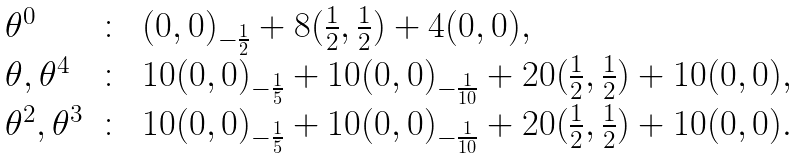Convert formula to latex. <formula><loc_0><loc_0><loc_500><loc_500>\begin{array} { l c l } \theta ^ { 0 } & \colon & ( 0 , 0 ) _ { - \frac { 1 } { 2 } } + 8 ( \frac { 1 } { 2 } , \frac { 1 } { 2 } ) + 4 ( 0 , 0 ) , \\ \theta , \theta ^ { 4 } & \colon & 1 0 ( 0 , 0 ) _ { - \frac { 1 } { 5 } } + 1 0 ( 0 , 0 ) _ { - \frac { 1 } { 1 0 } } + 2 0 ( \frac { 1 } { 2 } , \frac { 1 } { 2 } ) + 1 0 ( 0 , 0 ) , \\ \theta ^ { 2 } , \theta ^ { 3 } & \colon & 1 0 ( 0 , 0 ) _ { - \frac { 1 } { 5 } } + 1 0 ( 0 , 0 ) _ { - \frac { 1 } { 1 0 } } + 2 0 ( \frac { 1 } { 2 } , \frac { 1 } { 2 } ) + 1 0 ( 0 , 0 ) . \end{array}</formula> 